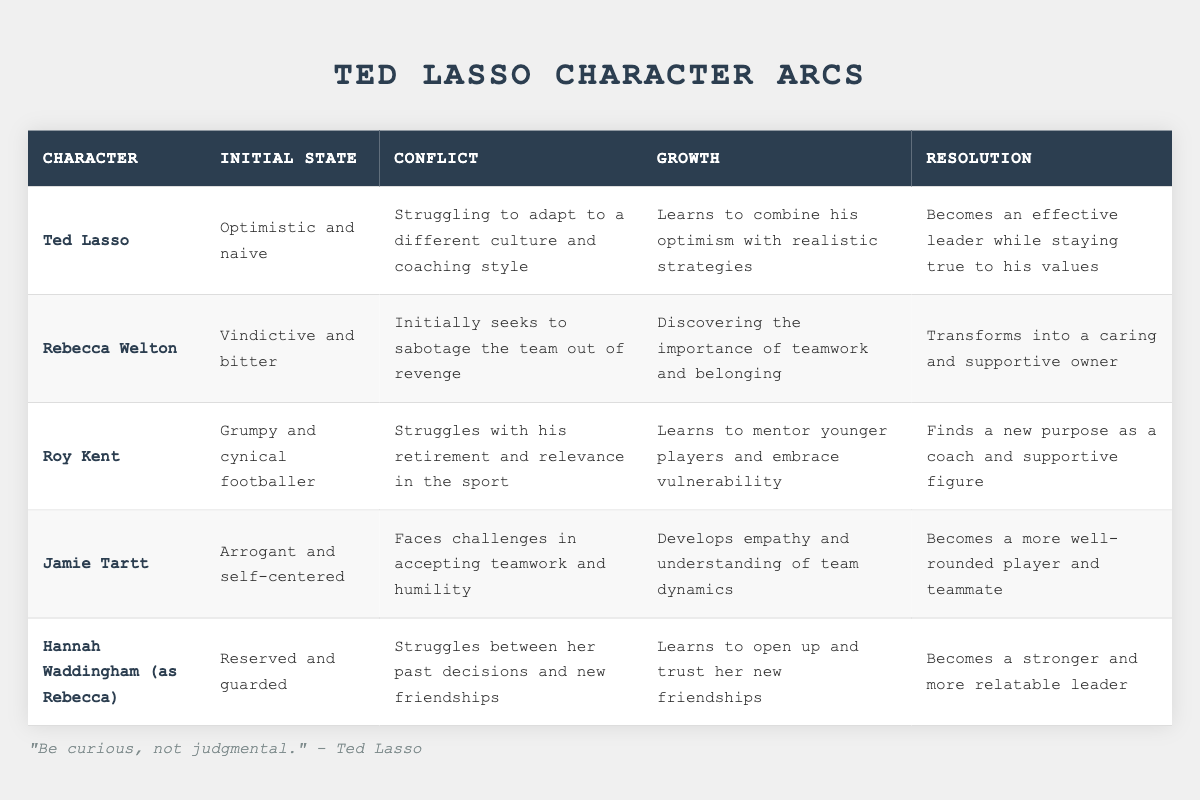What is the initial state of Ted Lasso? The table shows that Ted Lasso's initial state is "Optimistic and naive."
Answer: Optimistic and naive What conflict does Rebecca Welton face? The table states that Rebecca Welton's conflict is "Initially seeks to sabotage the team out of revenge."
Answer: Initially seeks to sabotage the team out of revenge How does Jamie Tartt grow throughout the series? According to the table, Jamie Tartt grows by "Developing empathy and understanding of team dynamics."
Answer: Developing empathy and understanding of team dynamics Which character transforms into a caring and supportive owner? The table lists Rebecca Welton as the character who "Transforms into a caring and supportive owner."
Answer: Rebecca Welton What is the resolution for Roy Kent? The resolution for Roy Kent is that he "Finds a new purpose as a coach and supportive figure."
Answer: Finds a new purpose as a coach and supportive figure Is Ted Lasso's character arc mostly positive? Yes, Ted Lasso's growth leads him to become an effective leader while staying true to his values, indicating a positive arc.
Answer: Yes Which character has a conflict related to their retirement? The table indicates that Roy Kent struggles with his retirement and relevance in the sport.
Answer: Roy Kent Are there any characters who start as cynical or bitter? Yes, both Roy Kent and Rebecca Welton start with cynical and bitter initial states, respectively.
Answer: Yes What character development does Rebecca experience? The table explains that Rebecca's development involves discovering the importance of teamwork and belonging, leading her to become more supportive.
Answer: Discovering the importance of teamwork and belonging Which character exhibits a transition from arrogance to a team-oriented mindset? Jamie Tartt's character arc encompasses a transition from being "Arrogant and self-centered" to understanding teamwork, indicating a shift.
Answer: Jamie Tartt Compare the initial states of Ted Lasso and Jamie Tartt. Ted Lasso starts as "Optimistic and naive," while Jamie Tartt begins as "Arrogant and self-centered," showing they have very different initial states.
Answer: Different initial states 